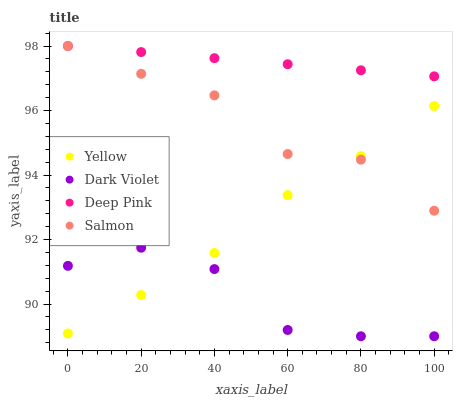Does Dark Violet have the minimum area under the curve?
Answer yes or no. Yes. Does Deep Pink have the maximum area under the curve?
Answer yes or no. Yes. Does Salmon have the minimum area under the curve?
Answer yes or no. No. Does Salmon have the maximum area under the curve?
Answer yes or no. No. Is Deep Pink the smoothest?
Answer yes or no. Yes. Is Salmon the roughest?
Answer yes or no. Yes. Is Dark Violet the smoothest?
Answer yes or no. No. Is Dark Violet the roughest?
Answer yes or no. No. Does Dark Violet have the lowest value?
Answer yes or no. Yes. Does Salmon have the lowest value?
Answer yes or no. No. Does Salmon have the highest value?
Answer yes or no. Yes. Does Dark Violet have the highest value?
Answer yes or no. No. Is Dark Violet less than Deep Pink?
Answer yes or no. Yes. Is Deep Pink greater than Dark Violet?
Answer yes or no. Yes. Does Dark Violet intersect Yellow?
Answer yes or no. Yes. Is Dark Violet less than Yellow?
Answer yes or no. No. Is Dark Violet greater than Yellow?
Answer yes or no. No. Does Dark Violet intersect Deep Pink?
Answer yes or no. No. 